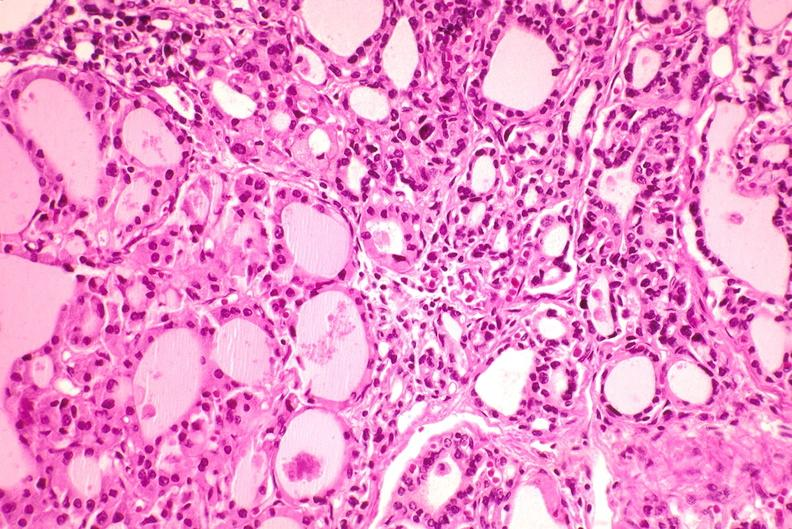s myocardial infarct present?
Answer the question using a single word or phrase. No 